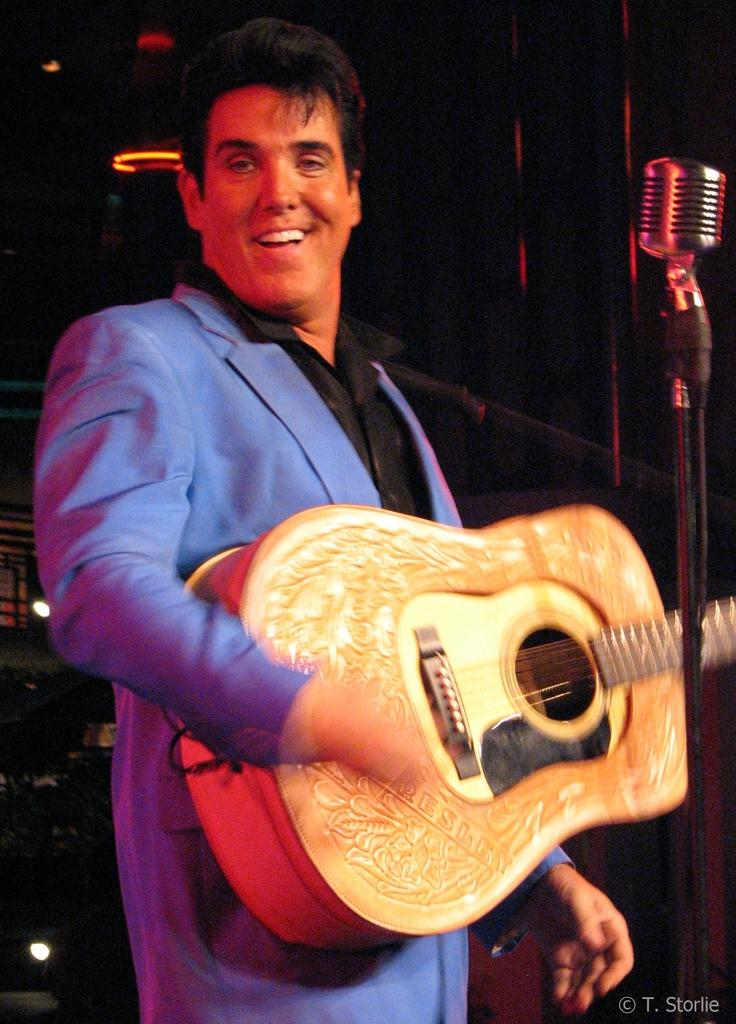Who is the main subject in the image? There is a man in the image. What is the man holding in the image? The man is holding a guitar. What color is the coat the man is wearing? The man is wearing a blue coat. What color is the shirt the man is wearing? The man is wearing a black shirt. What expression does the man have in the image? The man is smiling. What time of day is it in the image, considering the presence of the afternoon sun? There is no mention of the sun or time of day in the image, so it cannot be determined from the image alone. 